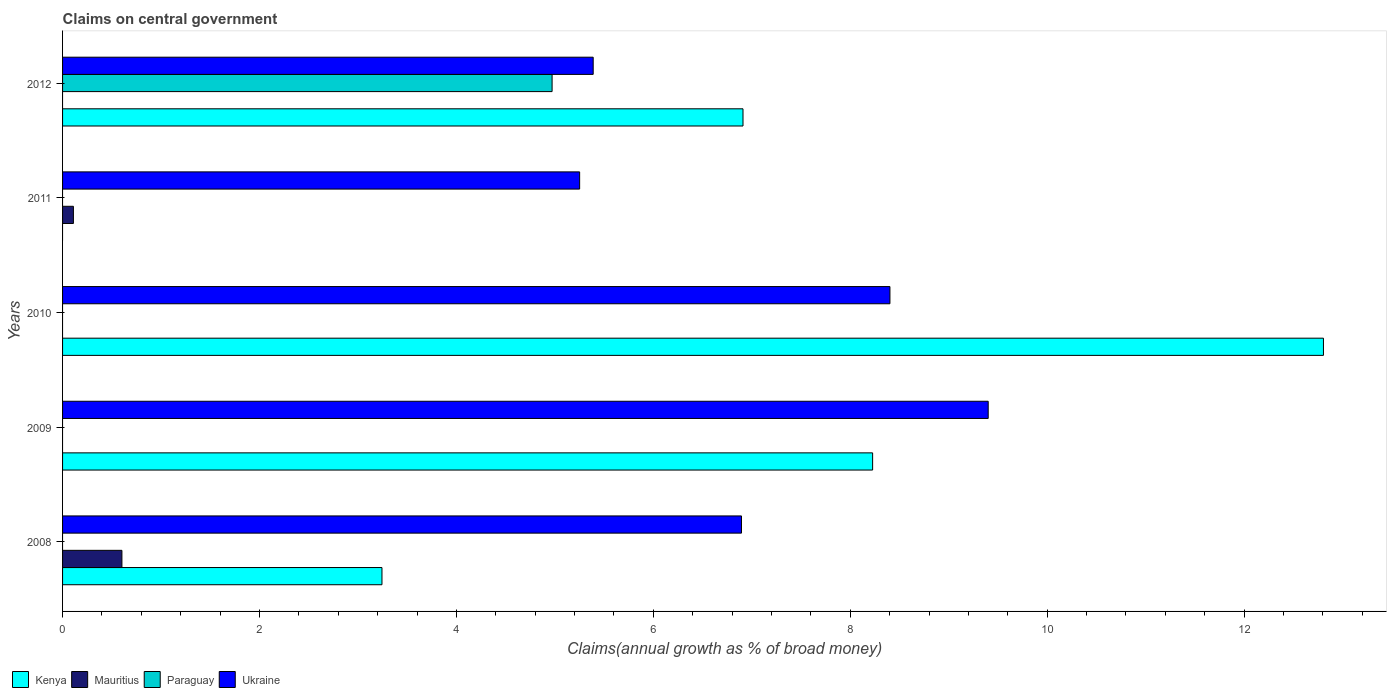Are the number of bars on each tick of the Y-axis equal?
Your answer should be compact. No. In how many cases, is the number of bars for a given year not equal to the number of legend labels?
Offer a terse response. 5. What is the percentage of broad money claimed on centeral government in Ukraine in 2008?
Offer a terse response. 6.9. Across all years, what is the maximum percentage of broad money claimed on centeral government in Mauritius?
Offer a terse response. 0.6. In which year was the percentage of broad money claimed on centeral government in Paraguay maximum?
Your response must be concise. 2012. What is the total percentage of broad money claimed on centeral government in Kenya in the graph?
Ensure brevity in your answer.  31.19. What is the difference between the percentage of broad money claimed on centeral government in Kenya in 2008 and that in 2009?
Provide a succinct answer. -4.98. What is the difference between the percentage of broad money claimed on centeral government in Kenya in 2008 and the percentage of broad money claimed on centeral government in Paraguay in 2012?
Your response must be concise. -1.73. What is the average percentage of broad money claimed on centeral government in Ukraine per year?
Provide a short and direct response. 7.07. In the year 2012, what is the difference between the percentage of broad money claimed on centeral government in Paraguay and percentage of broad money claimed on centeral government in Ukraine?
Offer a very short reply. -0.42. In how many years, is the percentage of broad money claimed on centeral government in Ukraine greater than 1.2000000000000002 %?
Your answer should be very brief. 5. What is the ratio of the percentage of broad money claimed on centeral government in Mauritius in 2008 to that in 2011?
Offer a very short reply. 5.48. Is the percentage of broad money claimed on centeral government in Kenya in 2009 less than that in 2010?
Your answer should be compact. Yes. What is the difference between the highest and the second highest percentage of broad money claimed on centeral government in Kenya?
Your answer should be compact. 4.58. What is the difference between the highest and the lowest percentage of broad money claimed on centeral government in Paraguay?
Provide a short and direct response. 4.97. Is the sum of the percentage of broad money claimed on centeral government in Kenya in 2008 and 2009 greater than the maximum percentage of broad money claimed on centeral government in Paraguay across all years?
Keep it short and to the point. Yes. Is it the case that in every year, the sum of the percentage of broad money claimed on centeral government in Paraguay and percentage of broad money claimed on centeral government in Ukraine is greater than the sum of percentage of broad money claimed on centeral government in Kenya and percentage of broad money claimed on centeral government in Mauritius?
Give a very brief answer. No. How many bars are there?
Offer a very short reply. 12. Are all the bars in the graph horizontal?
Make the answer very short. Yes. How many years are there in the graph?
Provide a short and direct response. 5. What is the difference between two consecutive major ticks on the X-axis?
Offer a very short reply. 2. Does the graph contain any zero values?
Keep it short and to the point. Yes. How are the legend labels stacked?
Your answer should be compact. Horizontal. What is the title of the graph?
Provide a succinct answer. Claims on central government. Does "Uzbekistan" appear as one of the legend labels in the graph?
Provide a succinct answer. No. What is the label or title of the X-axis?
Make the answer very short. Claims(annual growth as % of broad money). What is the Claims(annual growth as % of broad money) in Kenya in 2008?
Your answer should be very brief. 3.24. What is the Claims(annual growth as % of broad money) of Mauritius in 2008?
Provide a succinct answer. 0.6. What is the Claims(annual growth as % of broad money) of Paraguay in 2008?
Offer a very short reply. 0. What is the Claims(annual growth as % of broad money) of Ukraine in 2008?
Your response must be concise. 6.9. What is the Claims(annual growth as % of broad money) in Kenya in 2009?
Provide a succinct answer. 8.23. What is the Claims(annual growth as % of broad money) of Mauritius in 2009?
Keep it short and to the point. 0. What is the Claims(annual growth as % of broad money) of Ukraine in 2009?
Provide a short and direct response. 9.4. What is the Claims(annual growth as % of broad money) of Kenya in 2010?
Ensure brevity in your answer.  12.81. What is the Claims(annual growth as % of broad money) in Ukraine in 2010?
Give a very brief answer. 8.4. What is the Claims(annual growth as % of broad money) in Kenya in 2011?
Keep it short and to the point. 0. What is the Claims(annual growth as % of broad money) in Mauritius in 2011?
Ensure brevity in your answer.  0.11. What is the Claims(annual growth as % of broad money) in Paraguay in 2011?
Offer a terse response. 0. What is the Claims(annual growth as % of broad money) in Ukraine in 2011?
Your response must be concise. 5.25. What is the Claims(annual growth as % of broad money) in Kenya in 2012?
Your answer should be compact. 6.91. What is the Claims(annual growth as % of broad money) of Mauritius in 2012?
Your answer should be very brief. 0. What is the Claims(annual growth as % of broad money) of Paraguay in 2012?
Ensure brevity in your answer.  4.97. What is the Claims(annual growth as % of broad money) of Ukraine in 2012?
Offer a very short reply. 5.39. Across all years, what is the maximum Claims(annual growth as % of broad money) of Kenya?
Your answer should be compact. 12.81. Across all years, what is the maximum Claims(annual growth as % of broad money) in Mauritius?
Your answer should be compact. 0.6. Across all years, what is the maximum Claims(annual growth as % of broad money) in Paraguay?
Your response must be concise. 4.97. Across all years, what is the maximum Claims(annual growth as % of broad money) of Ukraine?
Offer a very short reply. 9.4. Across all years, what is the minimum Claims(annual growth as % of broad money) in Mauritius?
Make the answer very short. 0. Across all years, what is the minimum Claims(annual growth as % of broad money) of Ukraine?
Give a very brief answer. 5.25. What is the total Claims(annual growth as % of broad money) in Kenya in the graph?
Ensure brevity in your answer.  31.19. What is the total Claims(annual growth as % of broad money) in Mauritius in the graph?
Your answer should be very brief. 0.71. What is the total Claims(annual growth as % of broad money) in Paraguay in the graph?
Your answer should be compact. 4.97. What is the total Claims(annual growth as % of broad money) of Ukraine in the graph?
Your answer should be very brief. 35.34. What is the difference between the Claims(annual growth as % of broad money) in Kenya in 2008 and that in 2009?
Your answer should be very brief. -4.98. What is the difference between the Claims(annual growth as % of broad money) in Ukraine in 2008 and that in 2009?
Provide a short and direct response. -2.51. What is the difference between the Claims(annual growth as % of broad money) of Kenya in 2008 and that in 2010?
Your answer should be compact. -9.56. What is the difference between the Claims(annual growth as % of broad money) in Ukraine in 2008 and that in 2010?
Make the answer very short. -1.51. What is the difference between the Claims(annual growth as % of broad money) in Mauritius in 2008 and that in 2011?
Ensure brevity in your answer.  0.49. What is the difference between the Claims(annual growth as % of broad money) of Ukraine in 2008 and that in 2011?
Give a very brief answer. 1.64. What is the difference between the Claims(annual growth as % of broad money) in Kenya in 2008 and that in 2012?
Offer a terse response. -3.67. What is the difference between the Claims(annual growth as % of broad money) of Ukraine in 2008 and that in 2012?
Ensure brevity in your answer.  1.51. What is the difference between the Claims(annual growth as % of broad money) of Kenya in 2009 and that in 2010?
Ensure brevity in your answer.  -4.58. What is the difference between the Claims(annual growth as % of broad money) in Ukraine in 2009 and that in 2010?
Offer a terse response. 1. What is the difference between the Claims(annual growth as % of broad money) in Ukraine in 2009 and that in 2011?
Your answer should be very brief. 4.15. What is the difference between the Claims(annual growth as % of broad money) in Kenya in 2009 and that in 2012?
Ensure brevity in your answer.  1.32. What is the difference between the Claims(annual growth as % of broad money) of Ukraine in 2009 and that in 2012?
Make the answer very short. 4.01. What is the difference between the Claims(annual growth as % of broad money) of Ukraine in 2010 and that in 2011?
Offer a very short reply. 3.15. What is the difference between the Claims(annual growth as % of broad money) of Kenya in 2010 and that in 2012?
Give a very brief answer. 5.9. What is the difference between the Claims(annual growth as % of broad money) in Ukraine in 2010 and that in 2012?
Your response must be concise. 3.01. What is the difference between the Claims(annual growth as % of broad money) in Ukraine in 2011 and that in 2012?
Your response must be concise. -0.14. What is the difference between the Claims(annual growth as % of broad money) in Kenya in 2008 and the Claims(annual growth as % of broad money) in Ukraine in 2009?
Your answer should be very brief. -6.16. What is the difference between the Claims(annual growth as % of broad money) in Mauritius in 2008 and the Claims(annual growth as % of broad money) in Ukraine in 2009?
Give a very brief answer. -8.8. What is the difference between the Claims(annual growth as % of broad money) of Kenya in 2008 and the Claims(annual growth as % of broad money) of Ukraine in 2010?
Ensure brevity in your answer.  -5.16. What is the difference between the Claims(annual growth as % of broad money) of Mauritius in 2008 and the Claims(annual growth as % of broad money) of Ukraine in 2010?
Your response must be concise. -7.8. What is the difference between the Claims(annual growth as % of broad money) of Kenya in 2008 and the Claims(annual growth as % of broad money) of Mauritius in 2011?
Give a very brief answer. 3.13. What is the difference between the Claims(annual growth as % of broad money) of Kenya in 2008 and the Claims(annual growth as % of broad money) of Ukraine in 2011?
Your answer should be compact. -2.01. What is the difference between the Claims(annual growth as % of broad money) of Mauritius in 2008 and the Claims(annual growth as % of broad money) of Ukraine in 2011?
Offer a terse response. -4.65. What is the difference between the Claims(annual growth as % of broad money) in Kenya in 2008 and the Claims(annual growth as % of broad money) in Paraguay in 2012?
Your response must be concise. -1.73. What is the difference between the Claims(annual growth as % of broad money) in Kenya in 2008 and the Claims(annual growth as % of broad money) in Ukraine in 2012?
Give a very brief answer. -2.15. What is the difference between the Claims(annual growth as % of broad money) of Mauritius in 2008 and the Claims(annual growth as % of broad money) of Paraguay in 2012?
Your answer should be compact. -4.37. What is the difference between the Claims(annual growth as % of broad money) in Mauritius in 2008 and the Claims(annual growth as % of broad money) in Ukraine in 2012?
Make the answer very short. -4.79. What is the difference between the Claims(annual growth as % of broad money) of Kenya in 2009 and the Claims(annual growth as % of broad money) of Ukraine in 2010?
Give a very brief answer. -0.18. What is the difference between the Claims(annual growth as % of broad money) in Kenya in 2009 and the Claims(annual growth as % of broad money) in Mauritius in 2011?
Your answer should be compact. 8.12. What is the difference between the Claims(annual growth as % of broad money) in Kenya in 2009 and the Claims(annual growth as % of broad money) in Ukraine in 2011?
Your response must be concise. 2.98. What is the difference between the Claims(annual growth as % of broad money) in Kenya in 2009 and the Claims(annual growth as % of broad money) in Paraguay in 2012?
Your answer should be compact. 3.26. What is the difference between the Claims(annual growth as % of broad money) of Kenya in 2009 and the Claims(annual growth as % of broad money) of Ukraine in 2012?
Your response must be concise. 2.84. What is the difference between the Claims(annual growth as % of broad money) of Kenya in 2010 and the Claims(annual growth as % of broad money) of Mauritius in 2011?
Provide a succinct answer. 12.7. What is the difference between the Claims(annual growth as % of broad money) in Kenya in 2010 and the Claims(annual growth as % of broad money) in Ukraine in 2011?
Keep it short and to the point. 7.55. What is the difference between the Claims(annual growth as % of broad money) of Kenya in 2010 and the Claims(annual growth as % of broad money) of Paraguay in 2012?
Offer a terse response. 7.83. What is the difference between the Claims(annual growth as % of broad money) of Kenya in 2010 and the Claims(annual growth as % of broad money) of Ukraine in 2012?
Offer a very short reply. 7.42. What is the difference between the Claims(annual growth as % of broad money) of Mauritius in 2011 and the Claims(annual growth as % of broad money) of Paraguay in 2012?
Your answer should be very brief. -4.86. What is the difference between the Claims(annual growth as % of broad money) in Mauritius in 2011 and the Claims(annual growth as % of broad money) in Ukraine in 2012?
Your answer should be very brief. -5.28. What is the average Claims(annual growth as % of broad money) of Kenya per year?
Your answer should be very brief. 6.24. What is the average Claims(annual growth as % of broad money) in Mauritius per year?
Ensure brevity in your answer.  0.14. What is the average Claims(annual growth as % of broad money) in Ukraine per year?
Offer a terse response. 7.07. In the year 2008, what is the difference between the Claims(annual growth as % of broad money) of Kenya and Claims(annual growth as % of broad money) of Mauritius?
Give a very brief answer. 2.64. In the year 2008, what is the difference between the Claims(annual growth as % of broad money) of Kenya and Claims(annual growth as % of broad money) of Ukraine?
Your answer should be compact. -3.65. In the year 2008, what is the difference between the Claims(annual growth as % of broad money) of Mauritius and Claims(annual growth as % of broad money) of Ukraine?
Your answer should be very brief. -6.29. In the year 2009, what is the difference between the Claims(annual growth as % of broad money) in Kenya and Claims(annual growth as % of broad money) in Ukraine?
Ensure brevity in your answer.  -1.17. In the year 2010, what is the difference between the Claims(annual growth as % of broad money) of Kenya and Claims(annual growth as % of broad money) of Ukraine?
Offer a terse response. 4.4. In the year 2011, what is the difference between the Claims(annual growth as % of broad money) of Mauritius and Claims(annual growth as % of broad money) of Ukraine?
Make the answer very short. -5.14. In the year 2012, what is the difference between the Claims(annual growth as % of broad money) of Kenya and Claims(annual growth as % of broad money) of Paraguay?
Provide a succinct answer. 1.94. In the year 2012, what is the difference between the Claims(annual growth as % of broad money) in Kenya and Claims(annual growth as % of broad money) in Ukraine?
Offer a terse response. 1.52. In the year 2012, what is the difference between the Claims(annual growth as % of broad money) in Paraguay and Claims(annual growth as % of broad money) in Ukraine?
Your response must be concise. -0.42. What is the ratio of the Claims(annual growth as % of broad money) in Kenya in 2008 to that in 2009?
Your answer should be compact. 0.39. What is the ratio of the Claims(annual growth as % of broad money) of Ukraine in 2008 to that in 2009?
Your answer should be compact. 0.73. What is the ratio of the Claims(annual growth as % of broad money) in Kenya in 2008 to that in 2010?
Provide a short and direct response. 0.25. What is the ratio of the Claims(annual growth as % of broad money) of Ukraine in 2008 to that in 2010?
Your answer should be compact. 0.82. What is the ratio of the Claims(annual growth as % of broad money) of Mauritius in 2008 to that in 2011?
Keep it short and to the point. 5.48. What is the ratio of the Claims(annual growth as % of broad money) of Ukraine in 2008 to that in 2011?
Offer a very short reply. 1.31. What is the ratio of the Claims(annual growth as % of broad money) of Kenya in 2008 to that in 2012?
Keep it short and to the point. 0.47. What is the ratio of the Claims(annual growth as % of broad money) in Ukraine in 2008 to that in 2012?
Your answer should be compact. 1.28. What is the ratio of the Claims(annual growth as % of broad money) of Kenya in 2009 to that in 2010?
Make the answer very short. 0.64. What is the ratio of the Claims(annual growth as % of broad money) in Ukraine in 2009 to that in 2010?
Your answer should be compact. 1.12. What is the ratio of the Claims(annual growth as % of broad money) of Ukraine in 2009 to that in 2011?
Provide a succinct answer. 1.79. What is the ratio of the Claims(annual growth as % of broad money) of Kenya in 2009 to that in 2012?
Offer a very short reply. 1.19. What is the ratio of the Claims(annual growth as % of broad money) in Ukraine in 2009 to that in 2012?
Ensure brevity in your answer.  1.74. What is the ratio of the Claims(annual growth as % of broad money) in Ukraine in 2010 to that in 2011?
Your response must be concise. 1.6. What is the ratio of the Claims(annual growth as % of broad money) of Kenya in 2010 to that in 2012?
Your response must be concise. 1.85. What is the ratio of the Claims(annual growth as % of broad money) of Ukraine in 2010 to that in 2012?
Your answer should be compact. 1.56. What is the ratio of the Claims(annual growth as % of broad money) of Ukraine in 2011 to that in 2012?
Offer a very short reply. 0.97. What is the difference between the highest and the second highest Claims(annual growth as % of broad money) of Kenya?
Offer a very short reply. 4.58. What is the difference between the highest and the second highest Claims(annual growth as % of broad money) in Ukraine?
Make the answer very short. 1. What is the difference between the highest and the lowest Claims(annual growth as % of broad money) of Kenya?
Give a very brief answer. 12.81. What is the difference between the highest and the lowest Claims(annual growth as % of broad money) of Mauritius?
Offer a very short reply. 0.6. What is the difference between the highest and the lowest Claims(annual growth as % of broad money) of Paraguay?
Your answer should be very brief. 4.97. What is the difference between the highest and the lowest Claims(annual growth as % of broad money) of Ukraine?
Make the answer very short. 4.15. 